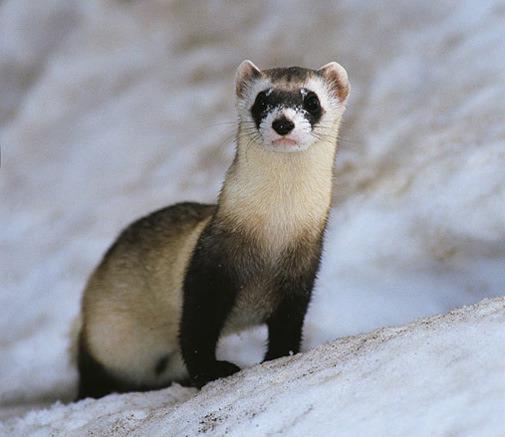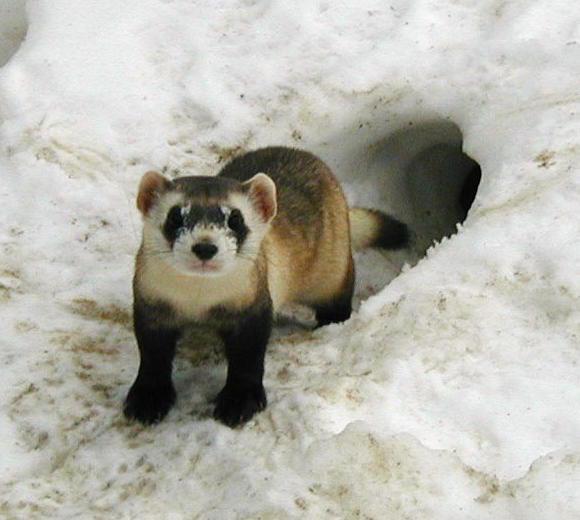The first image is the image on the left, the second image is the image on the right. Considering the images on both sides, is "There is only one weasel coming out of a hole in one of the pictures." valid? Answer yes or no. Yes. The first image is the image on the left, the second image is the image on the right. For the images displayed, is the sentence "At least one photograph shows exactly one animal with light brown, rather than black, markings around its eyes." factually correct? Answer yes or no. No. 